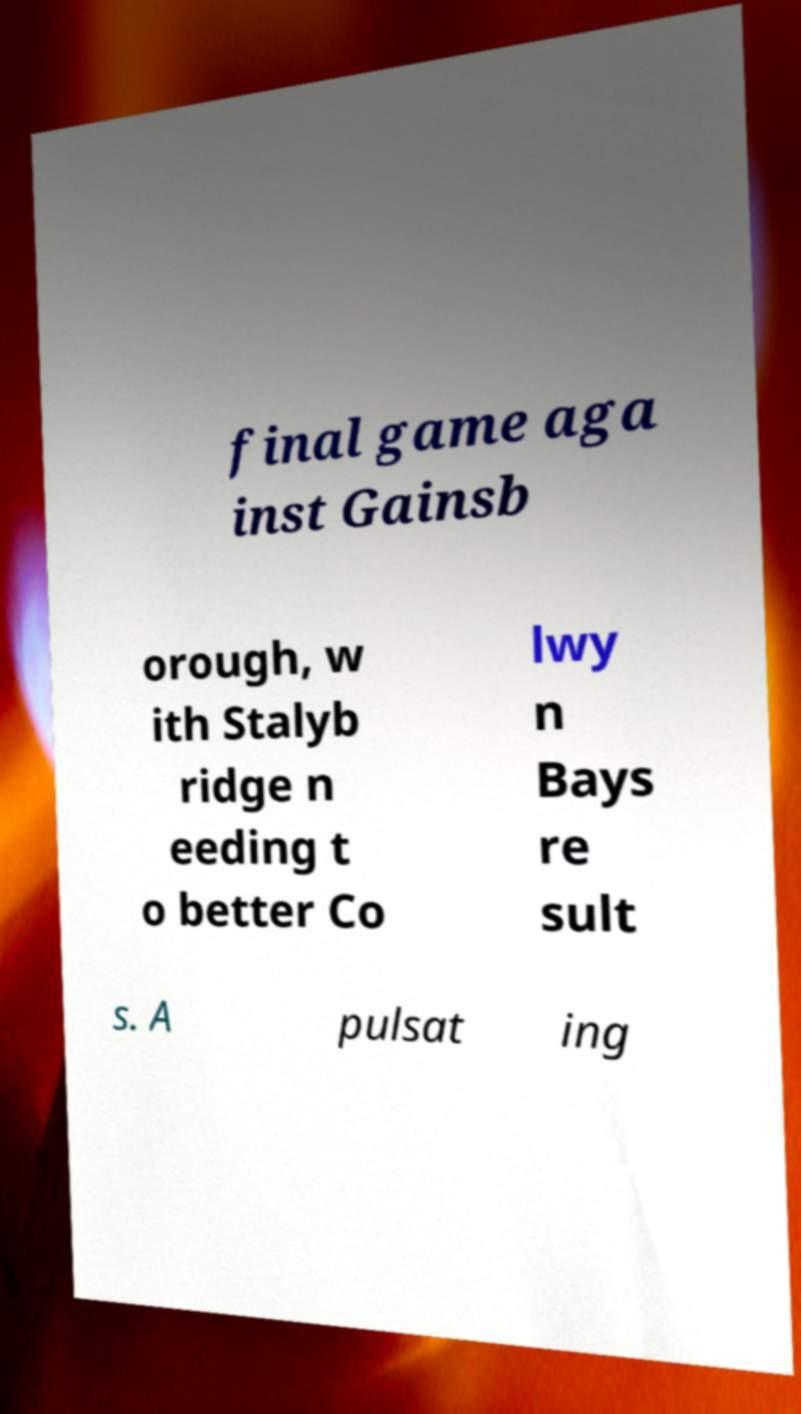Can you accurately transcribe the text from the provided image for me? final game aga inst Gainsb orough, w ith Stalyb ridge n eeding t o better Co lwy n Bays re sult s. A pulsat ing 